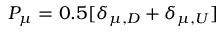<formula> <loc_0><loc_0><loc_500><loc_500>P _ { \mu } = 0 . 5 [ \delta _ { \mu , D } + \delta _ { \mu , U } ]</formula> 